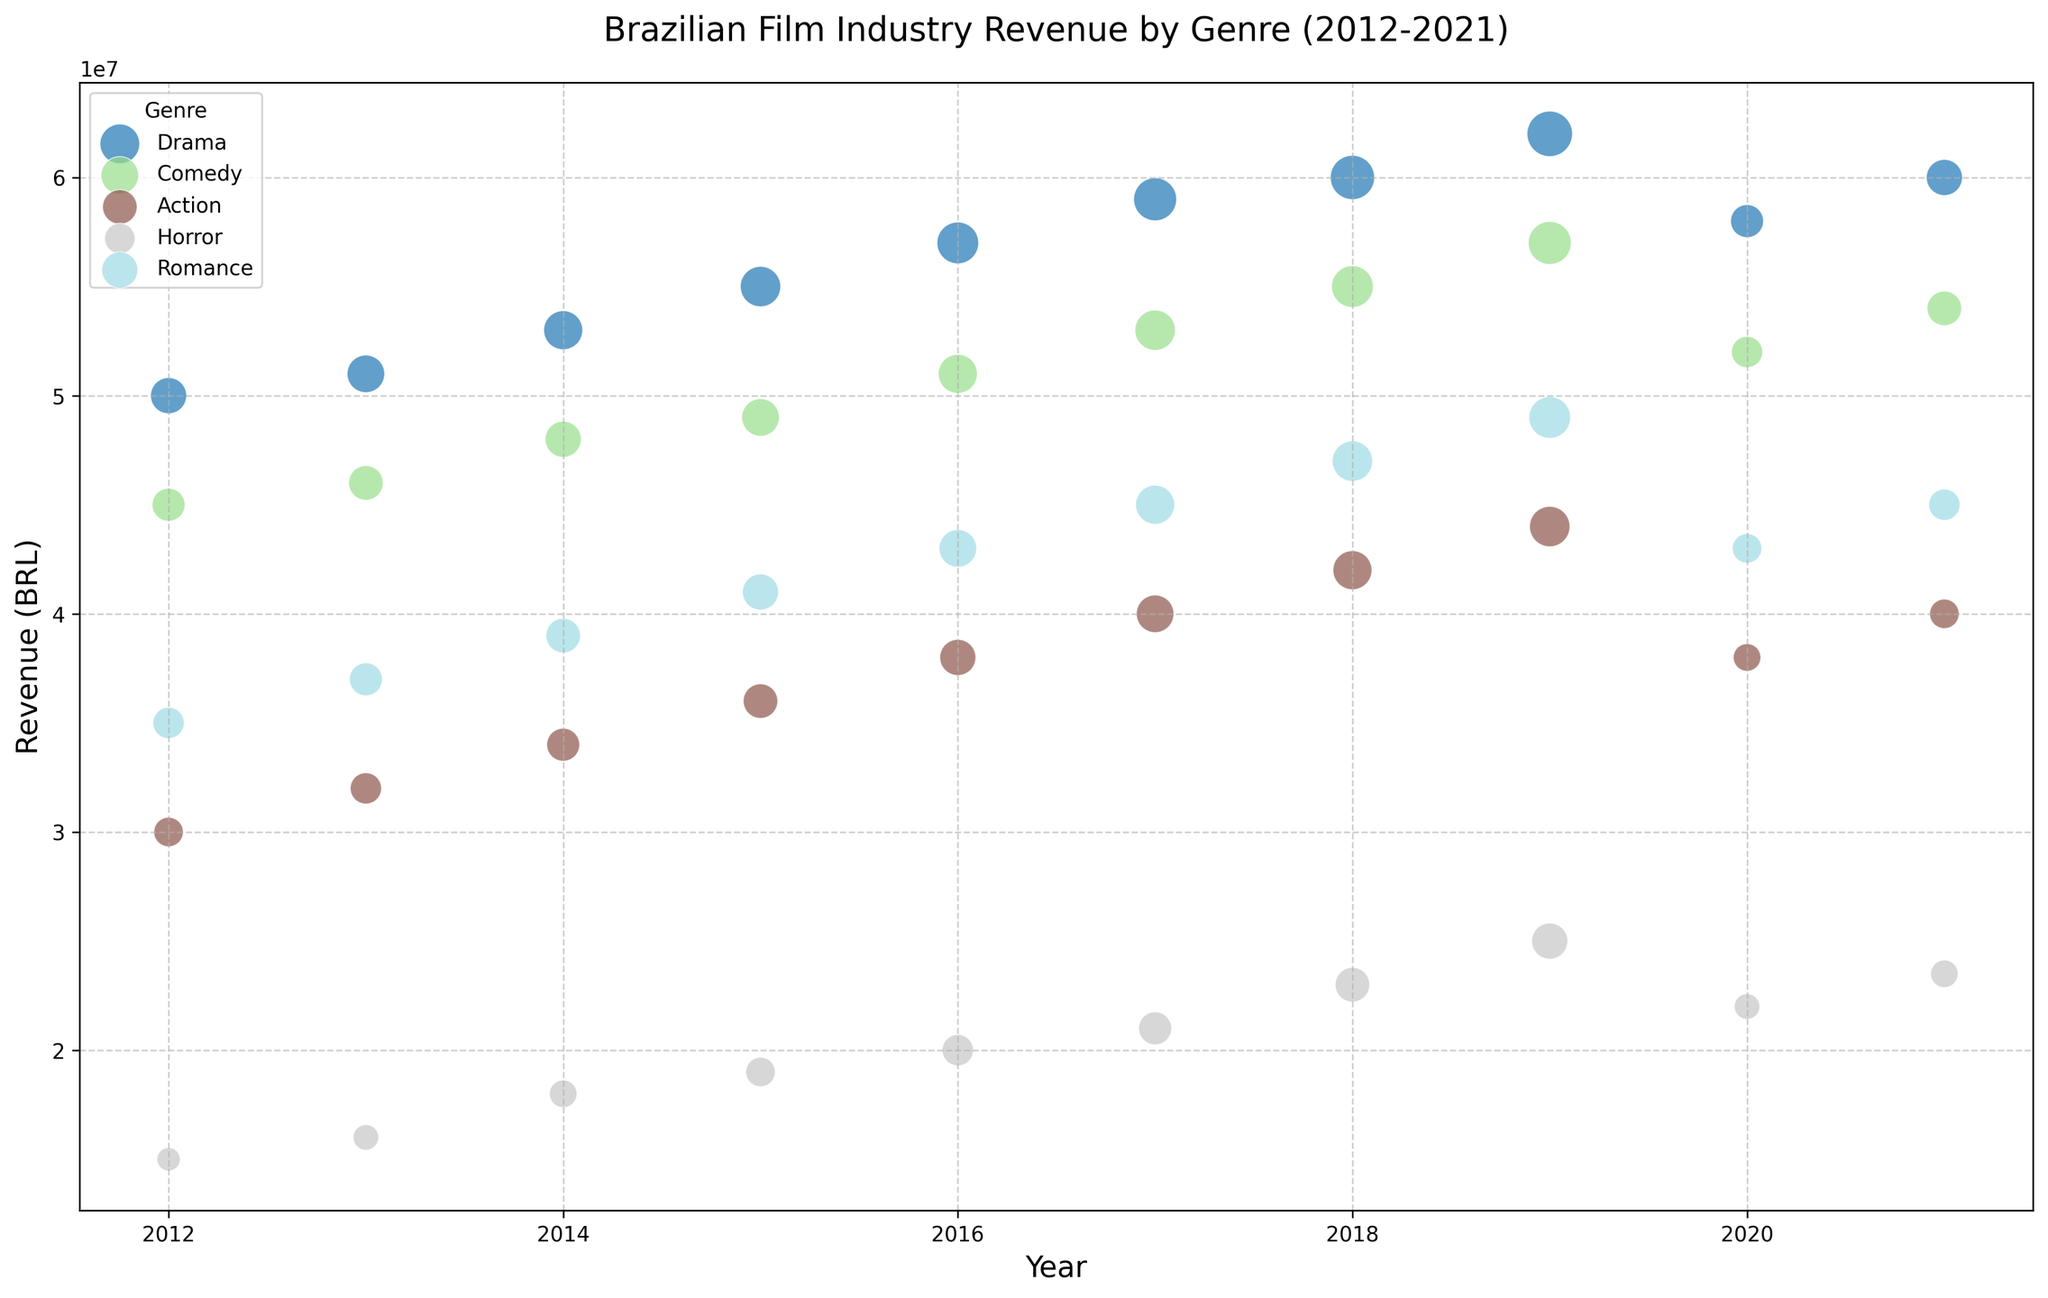What genre had the highest revenue in 2019? To determine the genre with the highest revenue in 2019, locate the bubbles corresponding to 2019 and compare their vertical positions on the y-axis. The highest point represents the highest revenue.
Answer: Drama How many Drama films were produced in 2020? Identify the bubble for the Drama genre in 2020 and check its size (noting that larger bubbles mean more films). The number next to the Drama genre for 2020 indicates the count of films produced.
Answer: 10 Which genre had the least noticeable impact due to the COVID-19 pandemic in 2020 in terms of revenue? Compare the revenues between 2019 and 2020 for all genres. The genre with the smallest decrease is the one least impacted.
Answer: Romance Which year saw the highest overall revenue for the action genre? Examine the height of the bubbles for Action across all years. The highest point reflects the highest revenue.
Answer: 2019 Between Drama and Comedy, which genre had more films produced annually on average over the decade? Calculate the average number of films produced each year for Drama and Comedy by summing their respective film counts over the years and dividing by the number of years (10).
Answer: Drama What is the relation between the number of Horror films produced and their revenue in 2019? Locate the Horror genre in 2019 and note both the height (revenue) and size (number of films) of the bubble. It shows the relationship between production volume and revenue.
Answer: High positive correlation Which genre showed the most consistent increase in revenue from 2012 to 2019? Compare the trend lines of all genres from 2012 to 2019 by looking at the bubble heights. The genre with a consistent upward trend presents the most consistent increase.
Answer: Drama How did the revenue for Comedy films change from 2018 to 2019? Observe the vertical position of the Comedy bubbles for 2018 and 2019. Calculate the difference between these heights to understand the change.
Answer: Increased Looking at Horror films, how did the number produced in 2020 compare to the average number produced from 2012 to 2019? Calculate the average number of Horror films produced from 2012 to 2019, then compare this average to the number produced in 2020. The average is (5+6+7+8+9+10+11+12)/8 = 8.5, which is higher than the 6 films produced in 2020.
Answer: Decreased Which genre had the smallest bubble in 2012? Identify all bubbles from 2012 and compare their sizes (smaller bubbles represent fewer films). The smallest bubble will indicate the genre with the least number of films.
Answer: Horror 